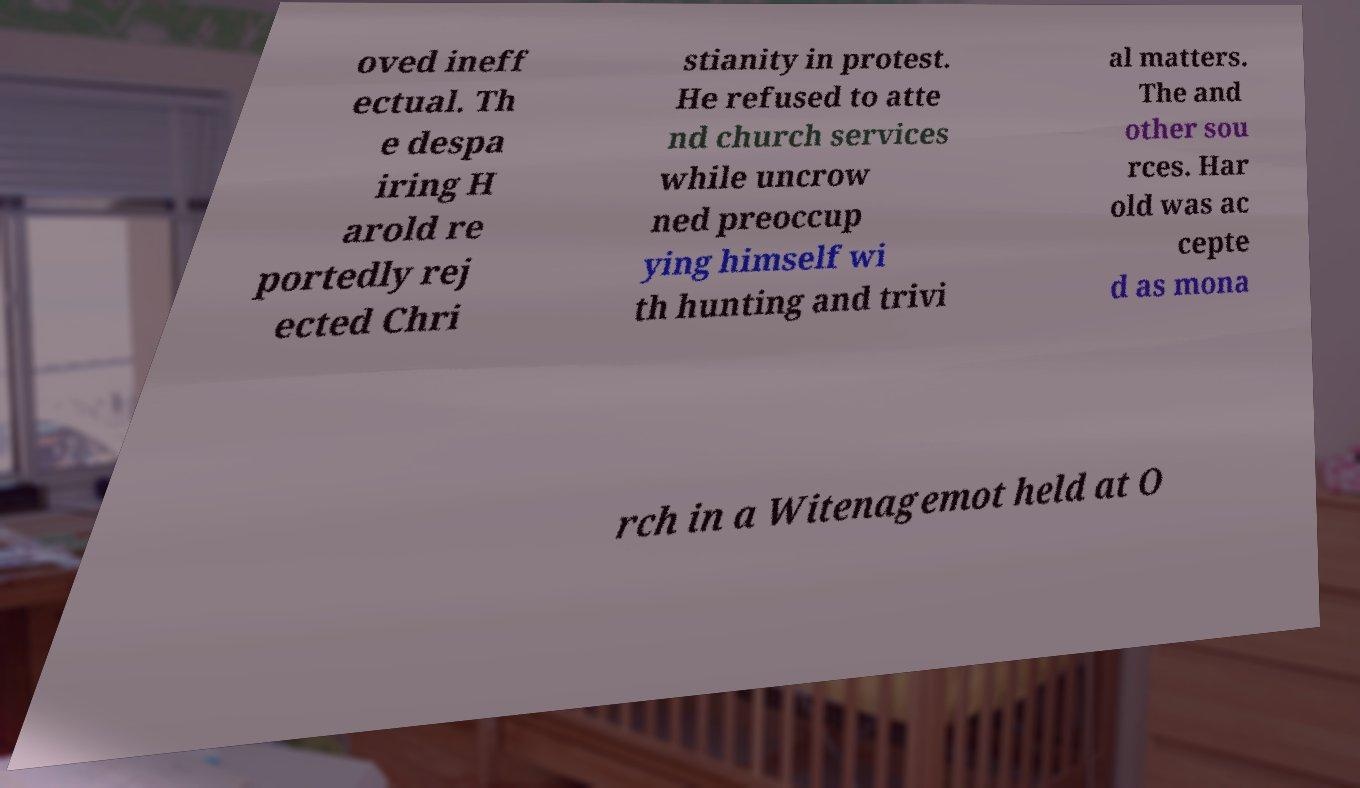Can you accurately transcribe the text from the provided image for me? oved ineff ectual. Th e despa iring H arold re portedly rej ected Chri stianity in protest. He refused to atte nd church services while uncrow ned preoccup ying himself wi th hunting and trivi al matters. The and other sou rces. Har old was ac cepte d as mona rch in a Witenagemot held at O 